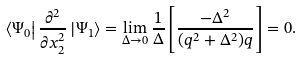Convert formula to latex. <formula><loc_0><loc_0><loc_500><loc_500>\left \langle \Psi _ { 0 } \right | \frac { \partial ^ { 2 } } { \partial x _ { 2 } ^ { 2 } } \left | \Psi _ { 1 } \right \rangle = \lim _ { \Delta \to 0 } \frac { 1 } { \Delta } \left [ \frac { - \Delta ^ { 2 } } { ( q ^ { 2 } + \Delta ^ { 2 } ) q } \right ] = 0 .</formula> 